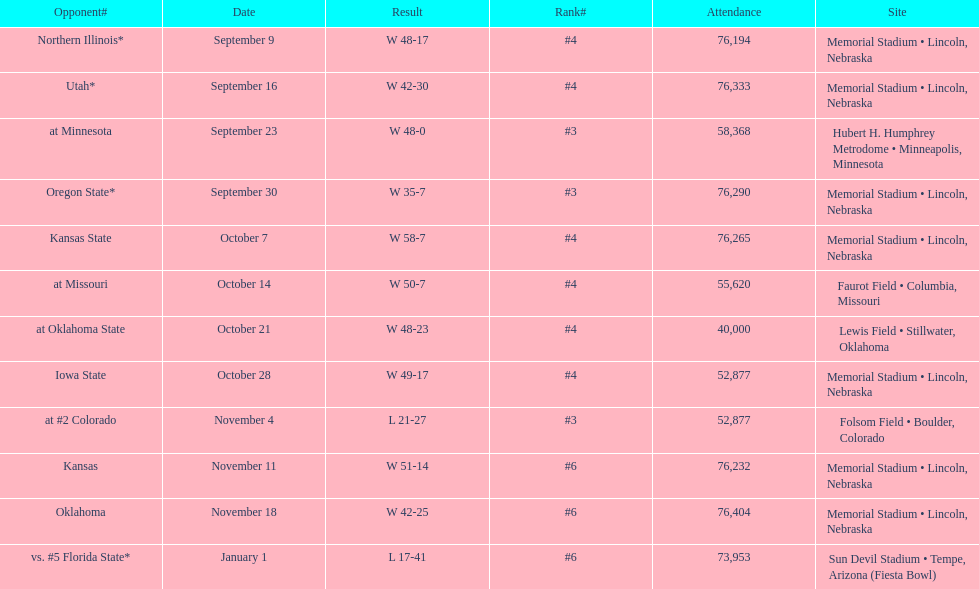What's the number of people who attended the oregon state game? 76,290. 